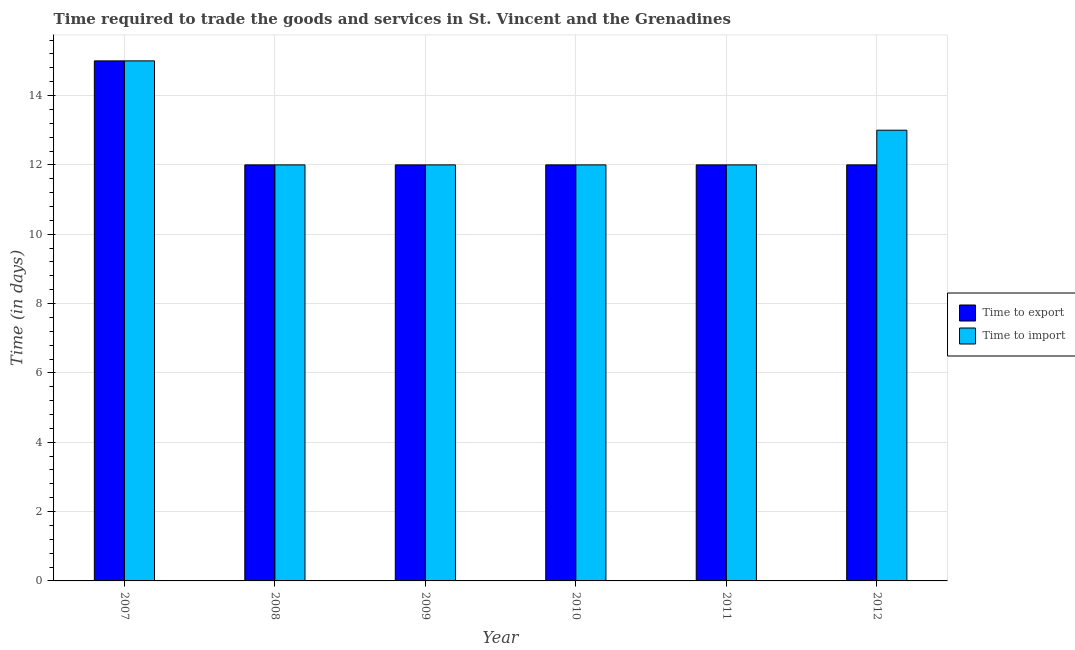How many different coloured bars are there?
Provide a short and direct response. 2. How many groups of bars are there?
Ensure brevity in your answer.  6. Are the number of bars on each tick of the X-axis equal?
Offer a very short reply. Yes. How many bars are there on the 1st tick from the left?
Your answer should be compact. 2. How many bars are there on the 3rd tick from the right?
Your answer should be very brief. 2. In how many cases, is the number of bars for a given year not equal to the number of legend labels?
Give a very brief answer. 0. What is the time to import in 2008?
Offer a very short reply. 12. Across all years, what is the maximum time to import?
Make the answer very short. 15. Across all years, what is the minimum time to import?
Offer a very short reply. 12. In which year was the time to import maximum?
Provide a short and direct response. 2007. In which year was the time to export minimum?
Provide a succinct answer. 2008. What is the total time to export in the graph?
Make the answer very short. 75. What is the difference between the time to import in 2008 and the time to export in 2007?
Your response must be concise. -3. What is the average time to import per year?
Offer a terse response. 12.67. In the year 2009, what is the difference between the time to import and time to export?
Your response must be concise. 0. In how many years, is the time to export greater than 8 days?
Your response must be concise. 6. What is the ratio of the time to export in 2008 to that in 2012?
Provide a short and direct response. 1. Is the time to import in 2007 less than that in 2011?
Keep it short and to the point. No. What is the difference between the highest and the second highest time to import?
Your response must be concise. 2. What is the difference between the highest and the lowest time to import?
Provide a succinct answer. 3. What does the 1st bar from the left in 2008 represents?
Give a very brief answer. Time to export. What does the 1st bar from the right in 2011 represents?
Your answer should be very brief. Time to import. Are all the bars in the graph horizontal?
Keep it short and to the point. No. What is the difference between two consecutive major ticks on the Y-axis?
Provide a succinct answer. 2. Does the graph contain any zero values?
Keep it short and to the point. No. What is the title of the graph?
Your answer should be compact. Time required to trade the goods and services in St. Vincent and the Grenadines. Does "RDB concessional" appear as one of the legend labels in the graph?
Provide a short and direct response. No. What is the label or title of the Y-axis?
Your answer should be compact. Time (in days). What is the Time (in days) in Time to import in 2007?
Offer a very short reply. 15. What is the Time (in days) in Time to export in 2008?
Provide a succinct answer. 12. What is the Time (in days) in Time to export in 2009?
Ensure brevity in your answer.  12. What is the Time (in days) in Time to import in 2010?
Your answer should be compact. 12. What is the Time (in days) of Time to import in 2011?
Offer a very short reply. 12. What is the Time (in days) of Time to export in 2012?
Your answer should be compact. 12. Across all years, what is the maximum Time (in days) of Time to import?
Your response must be concise. 15. Across all years, what is the minimum Time (in days) of Time to export?
Keep it short and to the point. 12. What is the difference between the Time (in days) in Time to import in 2007 and that in 2008?
Offer a terse response. 3. What is the difference between the Time (in days) of Time to import in 2007 and that in 2009?
Ensure brevity in your answer.  3. What is the difference between the Time (in days) of Time to import in 2007 and that in 2010?
Ensure brevity in your answer.  3. What is the difference between the Time (in days) of Time to export in 2007 and that in 2011?
Your answer should be compact. 3. What is the difference between the Time (in days) in Time to import in 2007 and that in 2012?
Ensure brevity in your answer.  2. What is the difference between the Time (in days) of Time to export in 2008 and that in 2010?
Keep it short and to the point. 0. What is the difference between the Time (in days) of Time to export in 2008 and that in 2011?
Provide a short and direct response. 0. What is the difference between the Time (in days) of Time to export in 2009 and that in 2010?
Your answer should be compact. 0. What is the difference between the Time (in days) in Time to export in 2009 and that in 2011?
Your response must be concise. 0. What is the difference between the Time (in days) of Time to export in 2009 and that in 2012?
Ensure brevity in your answer.  0. What is the difference between the Time (in days) in Time to import in 2009 and that in 2012?
Your response must be concise. -1. What is the difference between the Time (in days) of Time to import in 2010 and that in 2011?
Offer a terse response. 0. What is the difference between the Time (in days) of Time to export in 2011 and that in 2012?
Give a very brief answer. 0. What is the difference between the Time (in days) in Time to import in 2011 and that in 2012?
Offer a terse response. -1. What is the difference between the Time (in days) of Time to export in 2007 and the Time (in days) of Time to import in 2009?
Offer a very short reply. 3. What is the difference between the Time (in days) in Time to export in 2007 and the Time (in days) in Time to import in 2010?
Ensure brevity in your answer.  3. What is the difference between the Time (in days) of Time to export in 2007 and the Time (in days) of Time to import in 2011?
Provide a succinct answer. 3. What is the difference between the Time (in days) in Time to export in 2007 and the Time (in days) in Time to import in 2012?
Make the answer very short. 2. What is the difference between the Time (in days) in Time to export in 2008 and the Time (in days) in Time to import in 2009?
Offer a terse response. 0. What is the difference between the Time (in days) in Time to export in 2008 and the Time (in days) in Time to import in 2010?
Offer a terse response. 0. What is the difference between the Time (in days) in Time to export in 2008 and the Time (in days) in Time to import in 2012?
Your answer should be compact. -1. What is the difference between the Time (in days) of Time to export in 2009 and the Time (in days) of Time to import in 2010?
Provide a short and direct response. 0. What is the difference between the Time (in days) of Time to export in 2010 and the Time (in days) of Time to import in 2012?
Offer a terse response. -1. What is the average Time (in days) in Time to import per year?
Offer a terse response. 12.67. In the year 2007, what is the difference between the Time (in days) in Time to export and Time (in days) in Time to import?
Offer a terse response. 0. In the year 2008, what is the difference between the Time (in days) of Time to export and Time (in days) of Time to import?
Your answer should be compact. 0. In the year 2012, what is the difference between the Time (in days) in Time to export and Time (in days) in Time to import?
Offer a terse response. -1. What is the ratio of the Time (in days) of Time to export in 2007 to that in 2008?
Provide a succinct answer. 1.25. What is the ratio of the Time (in days) in Time to export in 2007 to that in 2009?
Ensure brevity in your answer.  1.25. What is the ratio of the Time (in days) in Time to import in 2007 to that in 2009?
Provide a succinct answer. 1.25. What is the ratio of the Time (in days) of Time to import in 2007 to that in 2010?
Offer a terse response. 1.25. What is the ratio of the Time (in days) of Time to export in 2007 to that in 2011?
Keep it short and to the point. 1.25. What is the ratio of the Time (in days) of Time to import in 2007 to that in 2012?
Offer a terse response. 1.15. What is the ratio of the Time (in days) of Time to export in 2008 to that in 2010?
Offer a terse response. 1. What is the ratio of the Time (in days) in Time to import in 2008 to that in 2010?
Give a very brief answer. 1. What is the ratio of the Time (in days) of Time to export in 2008 to that in 2012?
Make the answer very short. 1. What is the ratio of the Time (in days) of Time to export in 2009 to that in 2010?
Ensure brevity in your answer.  1. What is the ratio of the Time (in days) of Time to import in 2009 to that in 2010?
Your answer should be very brief. 1. What is the ratio of the Time (in days) of Time to import in 2009 to that in 2012?
Provide a short and direct response. 0.92. What is the ratio of the Time (in days) of Time to export in 2010 to that in 2011?
Ensure brevity in your answer.  1. What is the ratio of the Time (in days) in Time to export in 2010 to that in 2012?
Provide a succinct answer. 1. What is the ratio of the Time (in days) in Time to import in 2010 to that in 2012?
Keep it short and to the point. 0.92. What is the ratio of the Time (in days) in Time to import in 2011 to that in 2012?
Your answer should be compact. 0.92. What is the difference between the highest and the second highest Time (in days) of Time to export?
Provide a succinct answer. 3. What is the difference between the highest and the lowest Time (in days) of Time to export?
Your response must be concise. 3. What is the difference between the highest and the lowest Time (in days) in Time to import?
Your answer should be very brief. 3. 